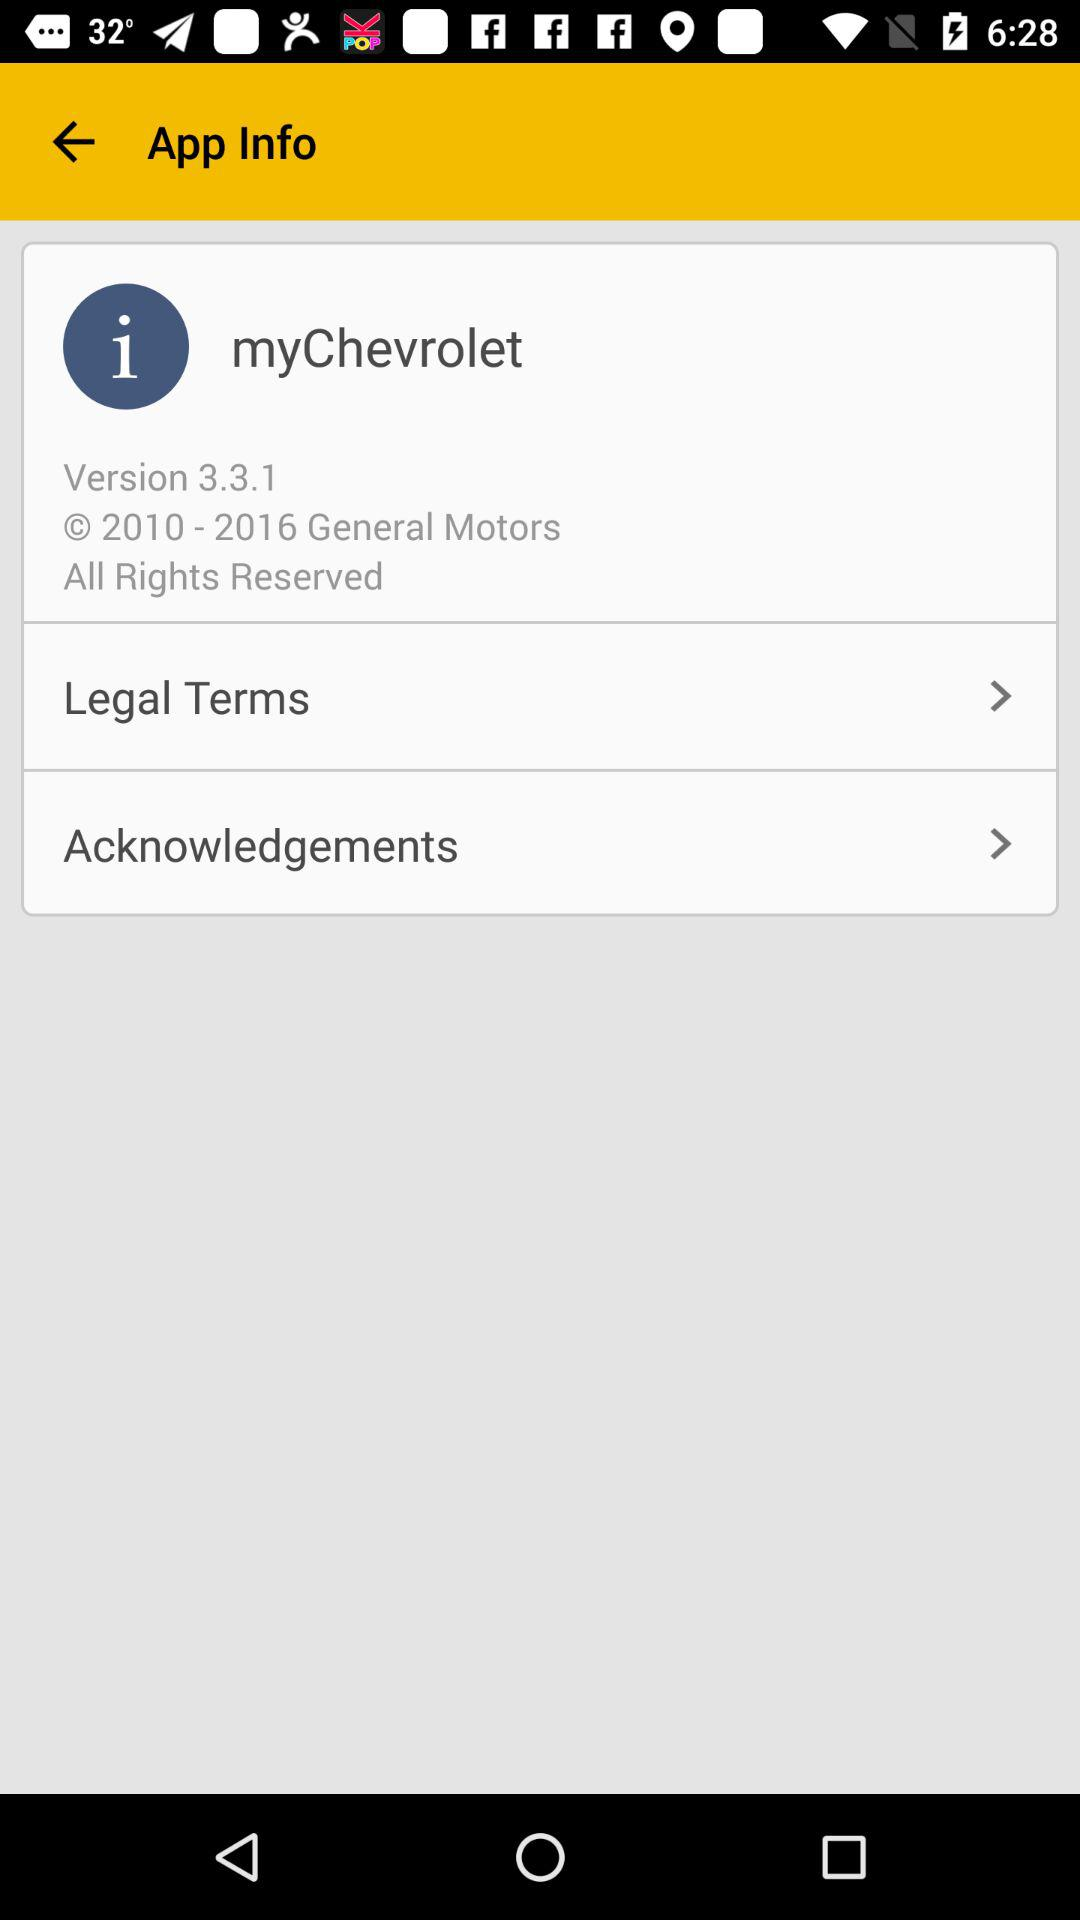What is the application name? The application name is "myChevrolet". 